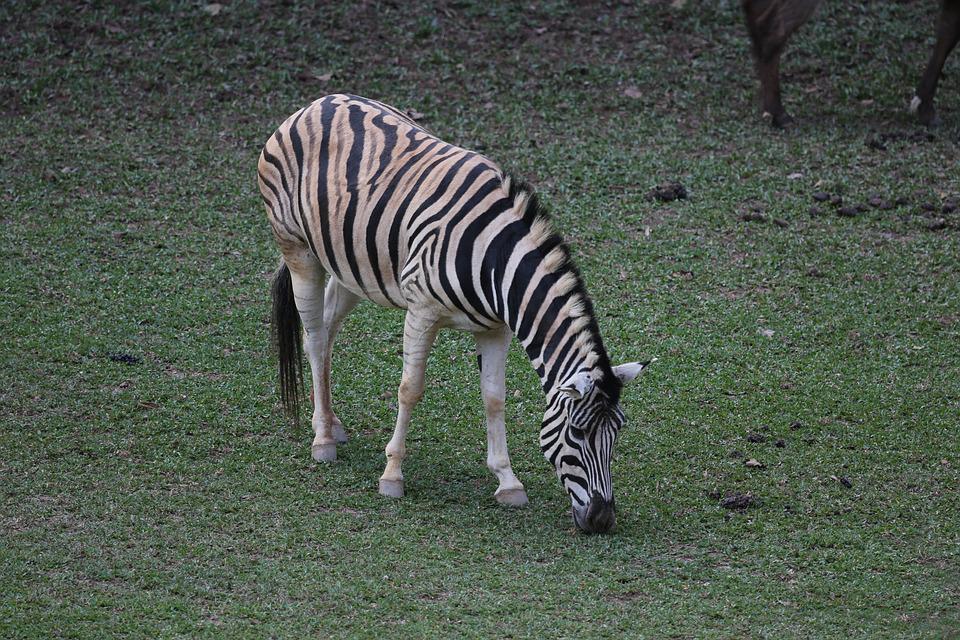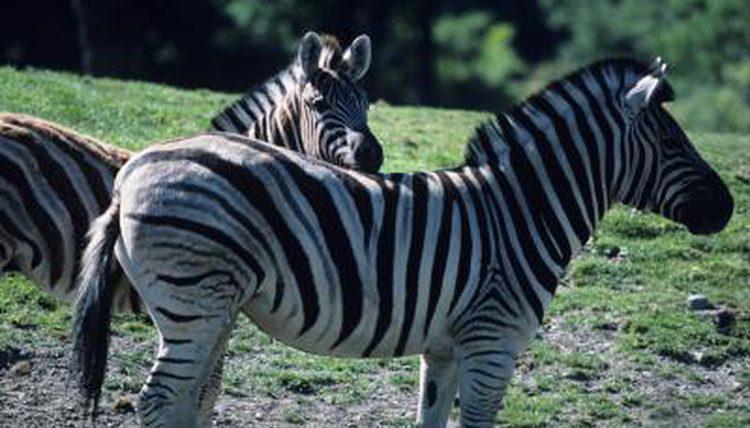The first image is the image on the left, the second image is the image on the right. For the images shown, is this caption "The left image contains one rightward turned standing zebra in profile, with its head bent to the grass, and the right image includes an adult standing leftward-turned zebra with one back hoof raised." true? Answer yes or no. No. The first image is the image on the left, the second image is the image on the right. Evaluate the accuracy of this statement regarding the images: "The right image contains two zebras.". Is it true? Answer yes or no. Yes. 